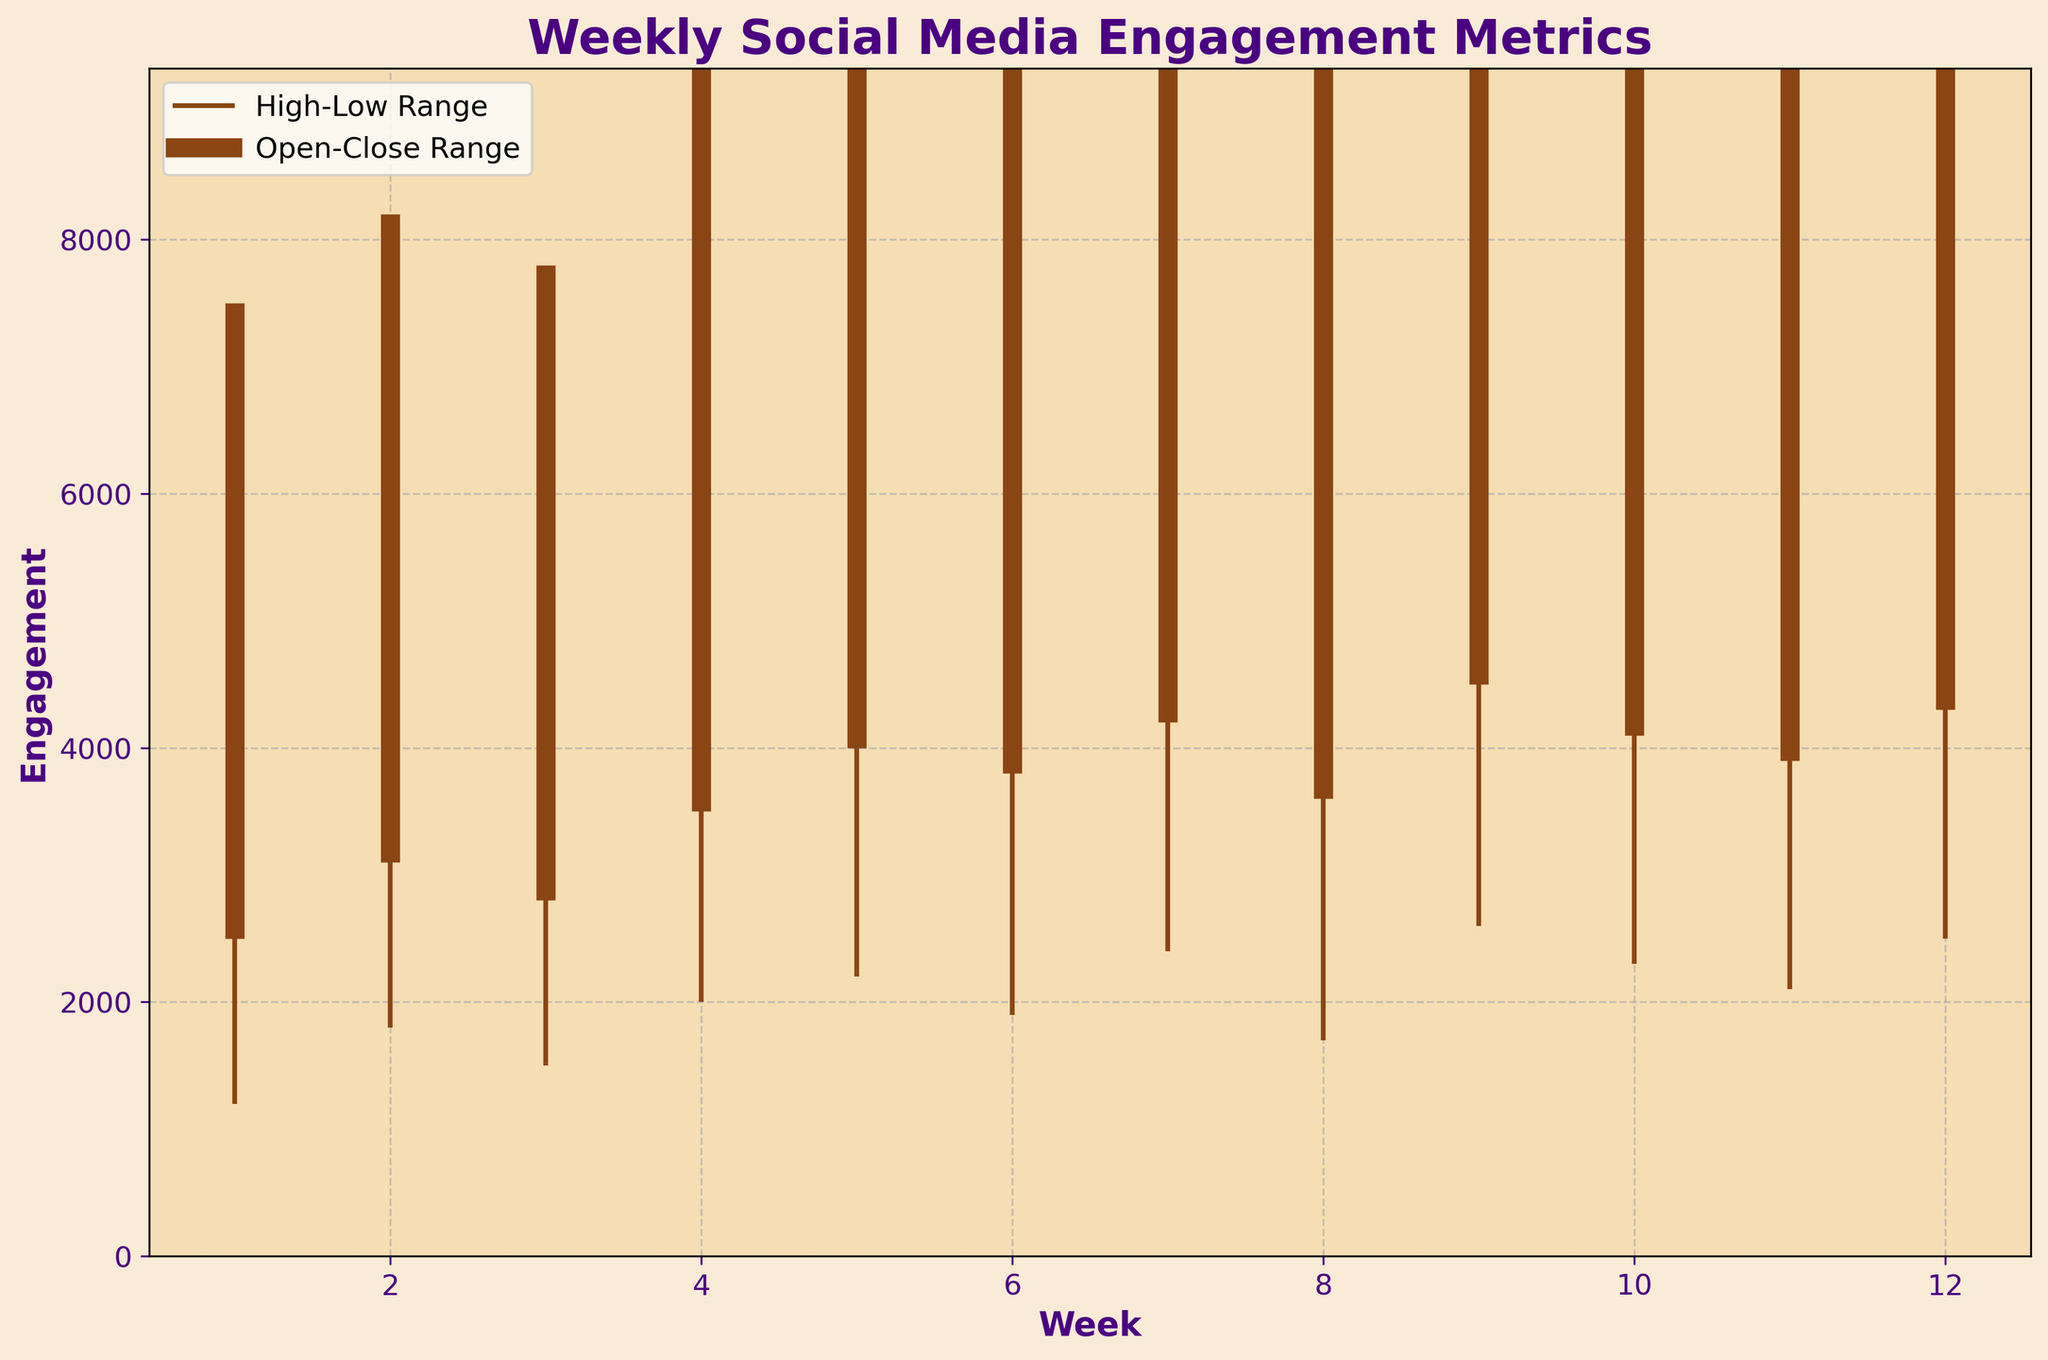What is the title of the figure? The title is typically found at the top of the chart and is designed to provide a brief description of what the chart is showing. In this figure, the title is prominently displayed.
Answer: Weekly Social Media Engagement Metrics What are the labels on the x-axis and y-axis? The x-axis label is located at the bottom of the figure and tells us what is measured along the horizontal axis, while the y-axis label is located on the left side of the figure and indicates what is measured along the vertical axis.
Answer: x-axis: Week, y-axis: Engagement Which week had the highest Peak Interactions? To find the week with the highest Peak Interactions, look at the maximum point of the high values. In the figure, the highest peak interaction is visibly indicated.
Answer: Week 9 What is the range of engagement for Week 5? The range of engagement for any week can be determined by subtracting the Lowest Engagement from the Peak Interactions value for that week. For Week 5, Peak Interactions are 7200 and Lowest Engagement is 2200, so 7200 - 2200 = 5000.
Answer: 5000 How did the Final Reach change between Week 3 and Week 4? To determine the change, subtract the Final Reach of Week 3 from the Final Reach of Week 4. Week 4 Final Reach is 9500 and Week 3 Final Reach is 7800. 9500 - 7800 = 1700.
Answer: Increased by 1700 Which week had the lowest Initial Views? By comparing all the Initial Views values, the smallest value can be found directly from the data plotted on the chart.
Answer: Week 1 What is the average Final Reach over the 12 weeks? Calculate the average by summing all Final Reach values and dividing by the number of weeks. Sum of Final Reach: 7500 + 8200 + 7800 + 9500 + 11000 + 10500 + 12000 + 9800 + 13500 + 12500 + 11200 + 13000 = 126500. The number of weeks is 12. Average = 126500 / 12 = 10541.67
Answer: 10541.67 Does Week 7 have a higher Peak Interactions than Week 6? Compare the Peak Interactions values of Week 7 and Week 6. Week 7 has 7800, and Week 6 has 6500. Since 7800 > 6500, Week 7's Peak Interactions is higher.
Answer: Yes Which week experienced the smallest difference between Peak Interactions and Lowest Engagement? For each week, subtract the Lowest Engagement value from the Peak Interactions value and find the smallest difference. Based on the values, the smallest difference can be visually inspected and calculated.
Answer: Week 2 What is the overall trend in Final Reach from Week 1 to Week 12? Observe the general movement of Final Reach values from Week 1 to Week 12. Check if values mostly increase, decrease, or stay the same.
Answer: Increasing 